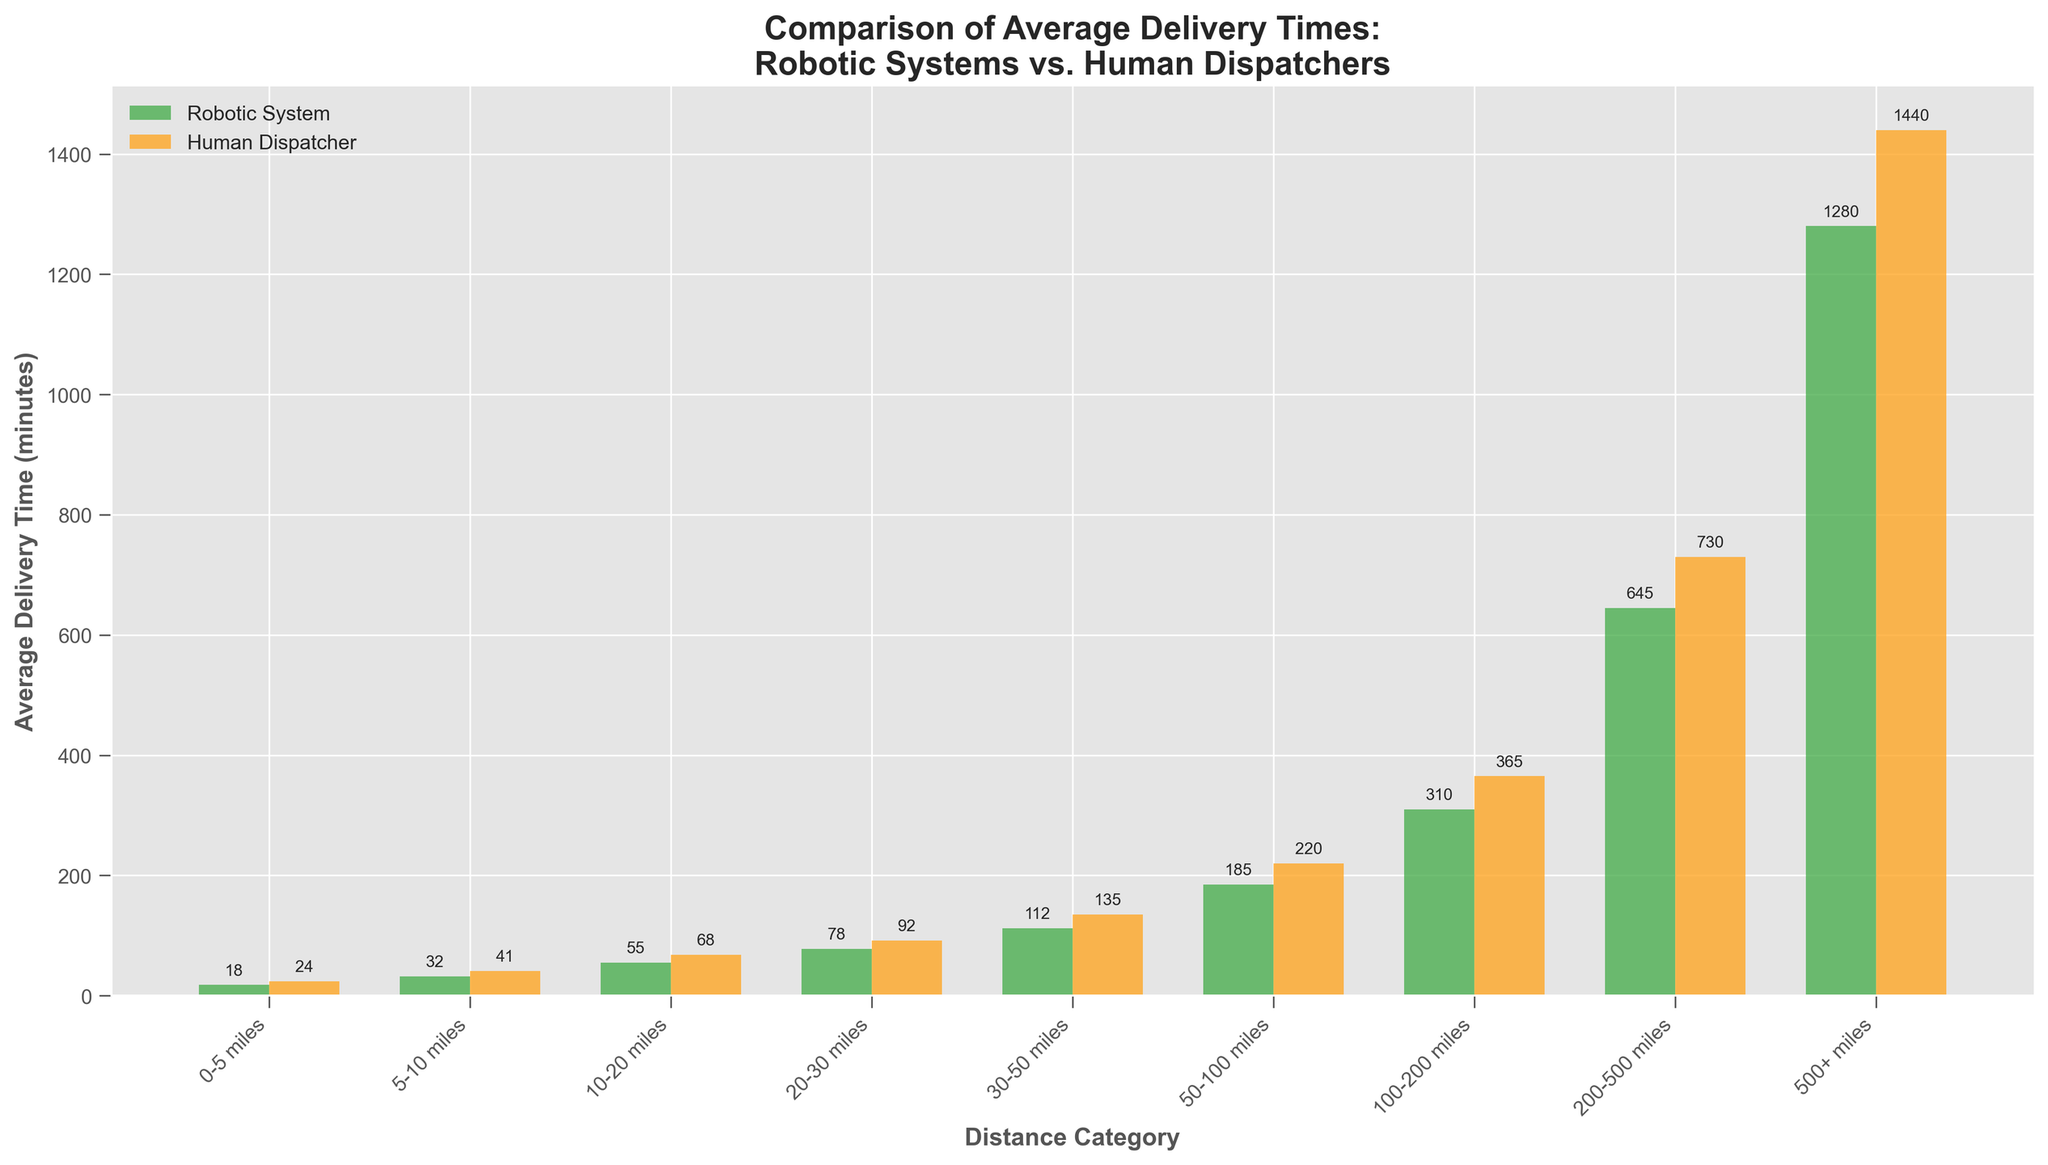Which distance category shows the greatest difference in average delivery time between robotic systems and human dispatchers? Look at the difference between the bars for each distance category. The category with the greatest difference is "500+ miles" where robotic systems have an average time of 1280 minutes and human dispatchers have an average time of 1440 minutes, making a difference of 160 minutes.
Answer: 500+ miles How much faster, on average, are robotic systems compared to human dispatchers for the 10-20 miles category? Subtract the average delivery time of the robotic system from the human dispatcher for the 10-20 miles category: 68 - 55 = 13 minutes faster.
Answer: 13 minutes In which distance category are robotic systems the least faster compared to human dispatchers? Compare the differences between the bars for each distance category. The category "0-5 miles" has the smallest difference where robotic systems have an average time of 18 minutes and human dispatchers have an average time of 24 minutes, making a difference of 6 minutes.
Answer: 0-5 miles What is the total average delivery time for robotic systems over all distance categories? Sum the delivery times for all categories for robotic systems: 18 + 32 + 55 + 78 + 112 + 185 + 310 + 645 + 1280 = 2715 minutes.
Answer: 2715 minutes What is the ratio of average delivery time between human dispatchers and robotic systems for the 50-100 miles category? Divide the average delivery time of human dispatchers by the robotic systems for the 50-100 miles category: 220 / 185 ≈ 1.19.
Answer: 1.19 Which distance category has the smallest difference in delivery times between robotic systems and human dispatchers? Look at the difference between the bars for each category. The "0-5 miles" category has the smallest difference with 6 minutes.
Answer: 0-5 miles By how many minutes does the average delivery time increase for robotic systems when moving from the 20-30 miles category to the 30-50 miles category? Subtract the average delivery time of the 20-30 miles category from the 30-50 miles category: 112 - 78 = 34 minutes increase.
Answer: 34 minutes Which system (robotic or human) shows a more consistent increment in delivery time as the distance category increases? Observe the trend in the bars' heights across distance categories. The robotic system shows a more consistent increment in delivery time as categories increase.
Answer: Robotic system What is the percentage reduction in average delivery time for robotic systems compared to human dispatchers in the 100-200 miles category? Calculate the difference and then the percentage: (365 - 310) / 365 * 100 ≈ 15.07%.
Answer: 15.07% Which distance category sees the largest percentage difference between robotic systems and human dispatchers? Calculate the percentage difference for each category and identify the largest one. For "200-500 miles": (730 - 645) / 730 * 100 ≈ 11.64%, which is the largest among all categories.
Answer: 200-500 miles 